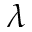<formula> <loc_0><loc_0><loc_500><loc_500>\lambda</formula> 